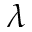<formula> <loc_0><loc_0><loc_500><loc_500>\lambda</formula> 